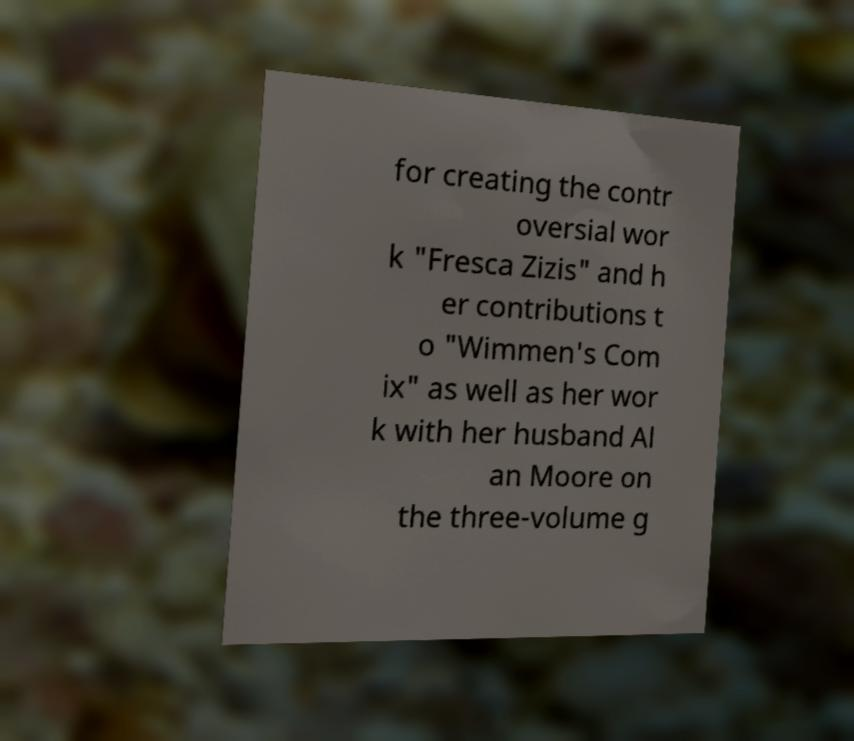Could you assist in decoding the text presented in this image and type it out clearly? for creating the contr oversial wor k "Fresca Zizis" and h er contributions t o "Wimmen's Com ix" as well as her wor k with her husband Al an Moore on the three-volume g 